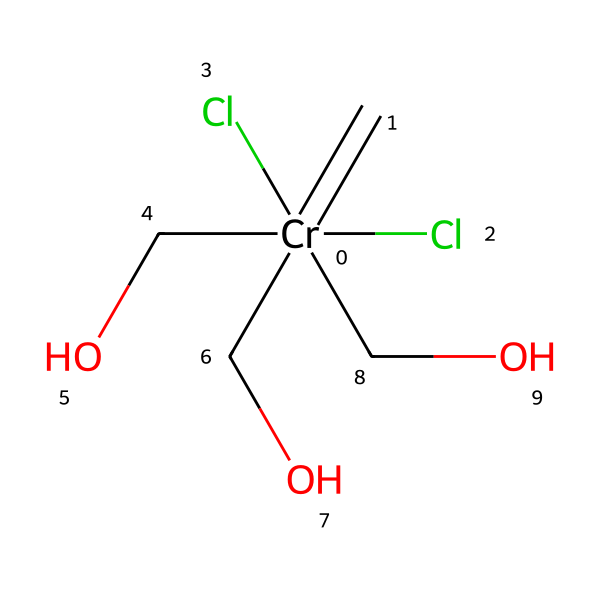What is the central metal in this carbene complex? The structure shows chromium (Cr) as the central atom surrounded by various substituents.
Answer: chromium How many chlorine atoms are present in this chemical? The structure has two chlorine (Cl) atoms directly attached to the chromium atom, as indicated by the "Cl" labels in the SMILES notation.
Answer: two What functional groups are present in this carbene complex? The complex contains three alcohol (hydroxyl) groups, represented by "CO" in the SMILES, which indicates the presence of -OH groups.
Answer: alcohol groups Which atom in this structure is likely involved in forming a carbene? The chromium atom is indicated as the center of this carbene complex, suggesting its central role in creating a carbene due to its bonding characteristics.
Answer: chromium Is this carbene complex likely to be stable or unstable? The presence of multiple chlorine atoms and alcohol groups suggests enhanced stability due to the electron-donating effects of these groups, which help stabilize the carbene.
Answer: stable What type of bonding can be inferred from the presence of a carbene in this complex? The carbene indicates potential for double bonding to the chromium atom, with significant characteristics of transition metal carbene complexes typically forming π-bonds.
Answer: π-bonding How does the presence of the chromium atom affect the overall properties of the carbene complex? Chromium as a transition metal can facilitate various oxidation states and can stabilize carbene structures, enhancing reactivity and properties in the complex.
Answer: enhances reactivity 